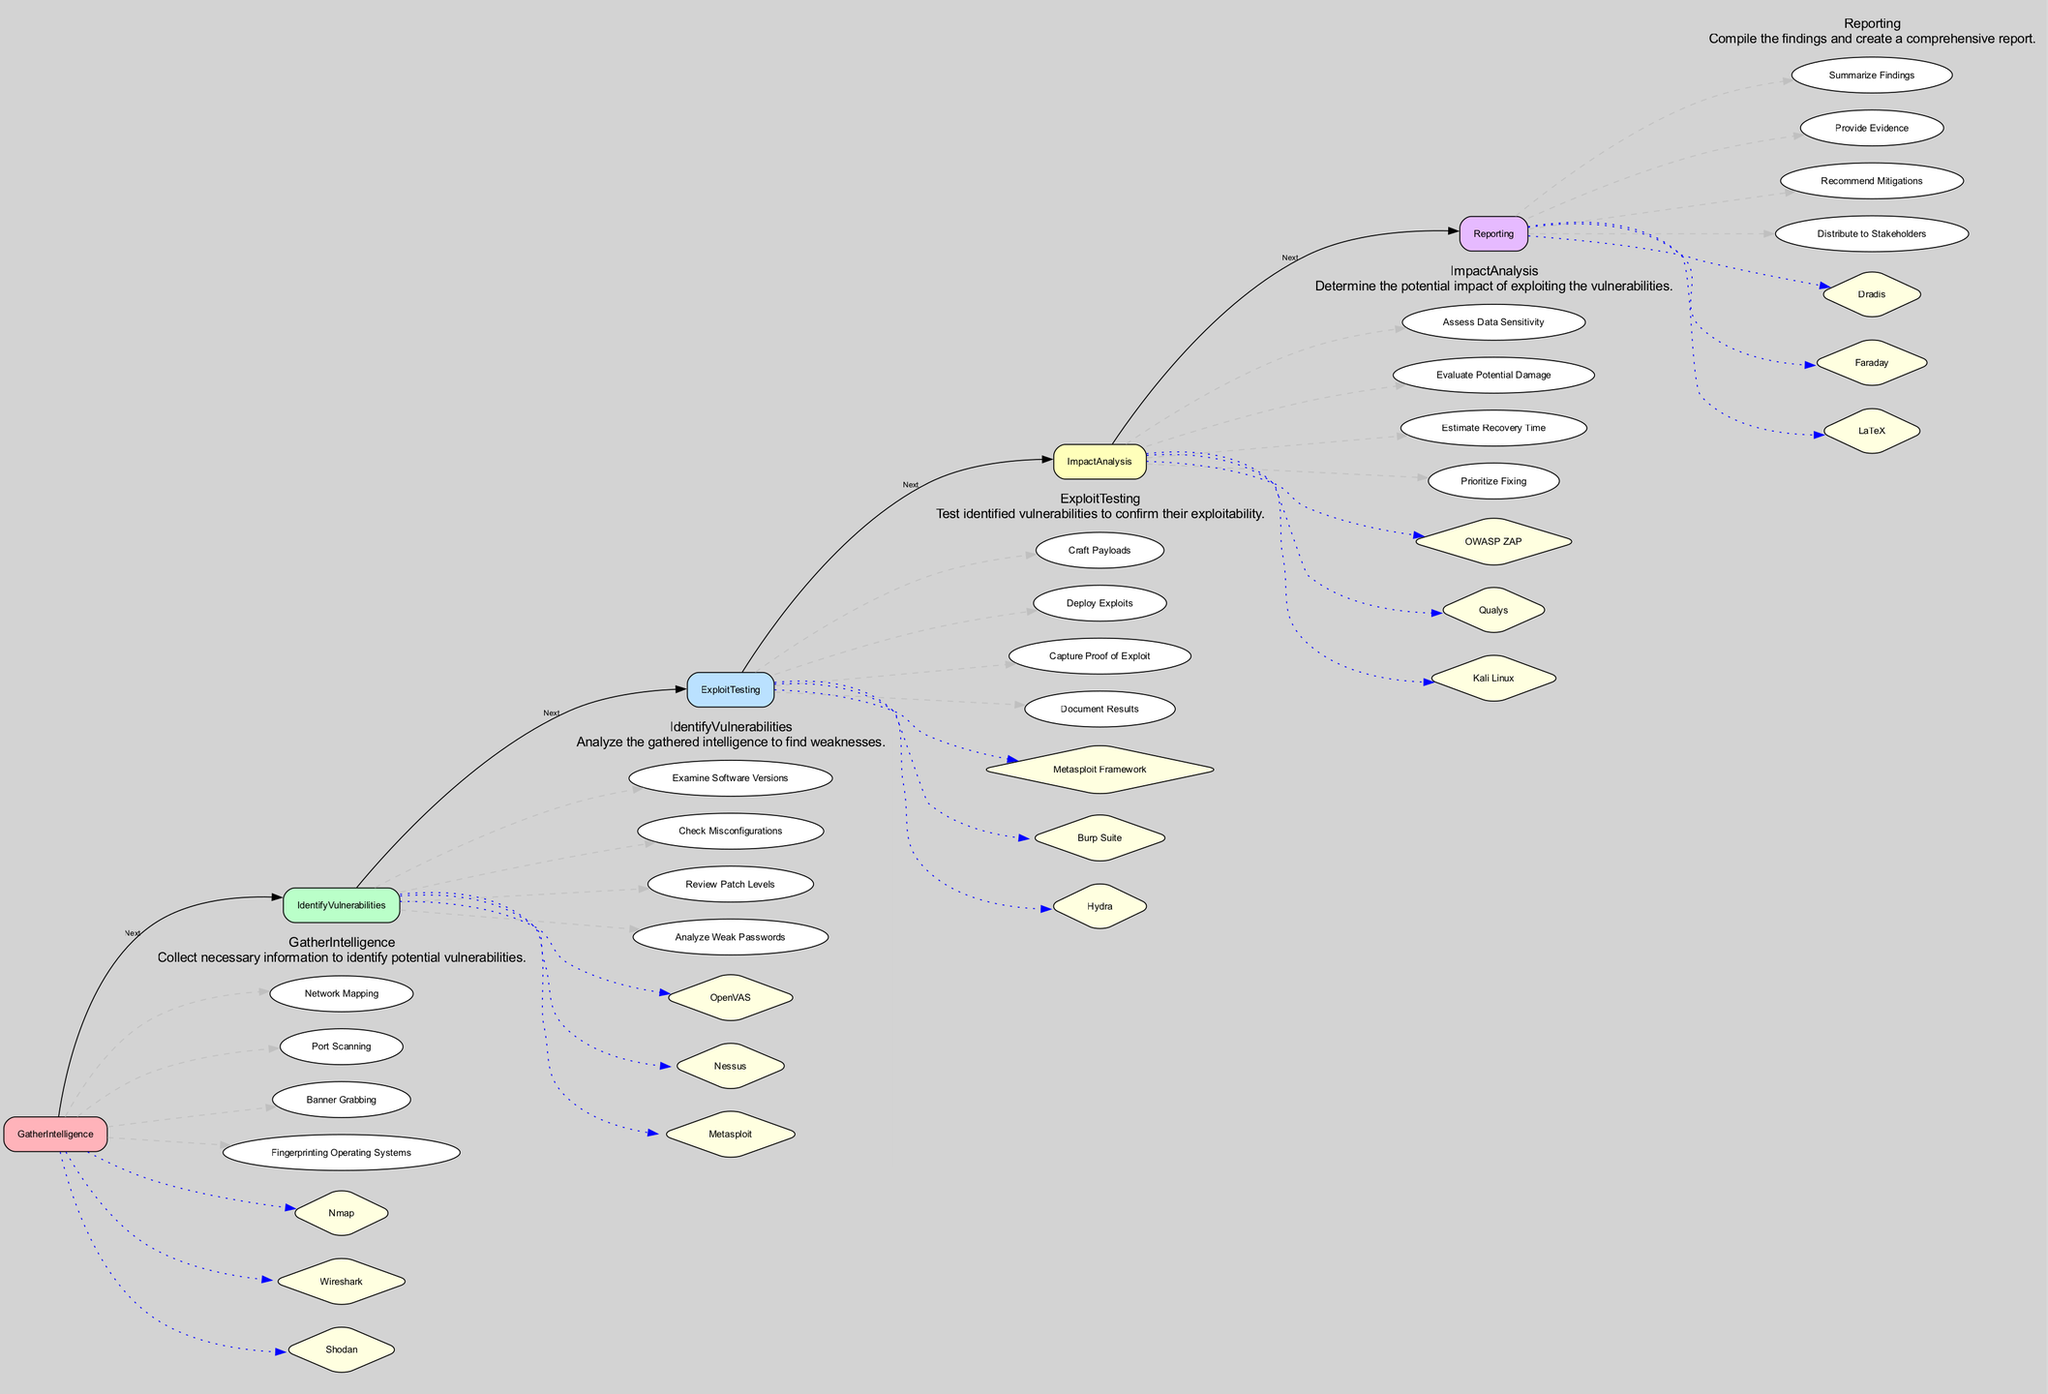What is the first step in the Vulnerability Assessment Workflow? The diagram outlines the Vulnerability Assessment Workflow in sequential steps, with "Gather Intelligence" being the first step listed.
Answer: Gather Intelligence How many tools are associated with the "Identify Vulnerabilities" step? By examining the "Identify Vulnerabilities" section in the diagram, we can see that there are three tools listed: OpenVAS, Nessus, and Metasploit.
Answer: 3 What is the last step in the workflow? Following the sequence of steps in the diagram, the final step is "Reporting," which compiles the findings of the assessment.
Answer: Reporting Which step includes "Capture Proof of Exploit"? Looking closely at the "Exploit Testing" section, we find that capturing proof of exploit is one of its core steps.
Answer: Exploit Testing What tool is used for vulnerability scanning? In the "Identify Vulnerabilities" step, the tool specifically mentioned for vulnerability scanning is Nessus.
Answer: Nessus How many steps are there in the "Impact Analysis"? The "Impact Analysis" section outlines four distinct steps: Assess Data Sensitivity, Evaluate Potential Damage, Estimate Recovery Time, and Prioritize Fixing.
Answer: 4 Which two steps are connected by the label "Next"? The workflow connections indicate that "Identify Vulnerabilities" follows "Gather Intelligence," and "Exploit Testing" follows "Identify Vulnerabilities"; thus, these two pairs are connected by the label "Next."
Answer: Identify Vulnerabilities and Exploit Testing What type of node represents the tools in the diagram? The tools in the diagram are represented as diamond-shaped nodes, which clearly differentiate them from the steps that are shown in rectangular boxes.
Answer: Diamond-shaped What is the primary function of the "Gather Intelligence" step? The description within the "Gather Intelligence" section indicates its primary function is to collect necessary information to identify potential vulnerabilities.
Answer: Collect information 